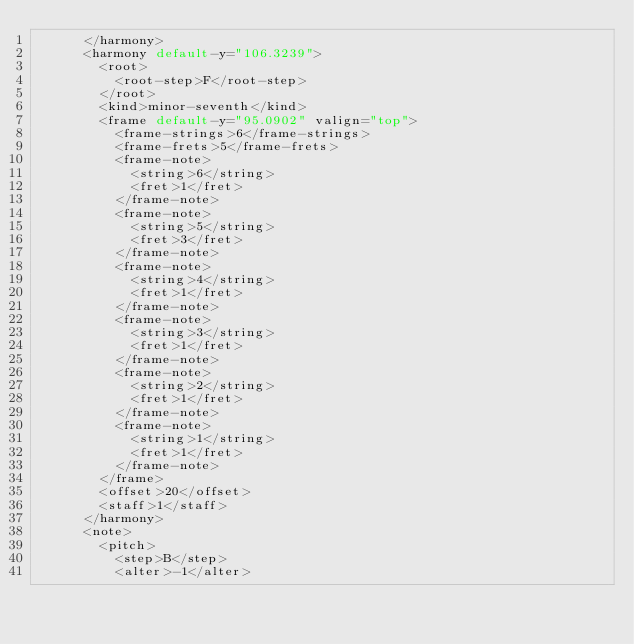Convert code to text. <code><loc_0><loc_0><loc_500><loc_500><_XML_>			</harmony>
			<harmony default-y="106.3239">
				<root>
					<root-step>F</root-step>
				</root>
				<kind>minor-seventh</kind>
				<frame default-y="95.0902" valign="top">
					<frame-strings>6</frame-strings>
					<frame-frets>5</frame-frets>
					<frame-note>
						<string>6</string>
						<fret>1</fret>
					</frame-note>
					<frame-note>
						<string>5</string>
						<fret>3</fret>
					</frame-note>
					<frame-note>
						<string>4</string>
						<fret>1</fret>
					</frame-note>
					<frame-note>
						<string>3</string>
						<fret>1</fret>
					</frame-note>
					<frame-note>
						<string>2</string>
						<fret>1</fret>
					</frame-note>
					<frame-note>
						<string>1</string>
						<fret>1</fret>
					</frame-note>
				</frame>
				<offset>20</offset>
				<staff>1</staff>
			</harmony>
			<note>
				<pitch>
					<step>B</step>
					<alter>-1</alter></code> 